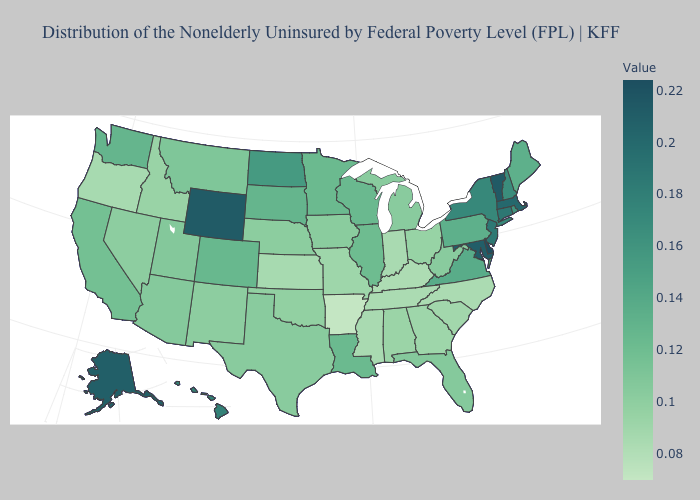Does Arkansas have the lowest value in the USA?
Quick response, please. Yes. Does Texas have the lowest value in the USA?
Answer briefly. No. Among the states that border Nebraska , does Iowa have the highest value?
Quick response, please. No. Does the map have missing data?
Give a very brief answer. No. 